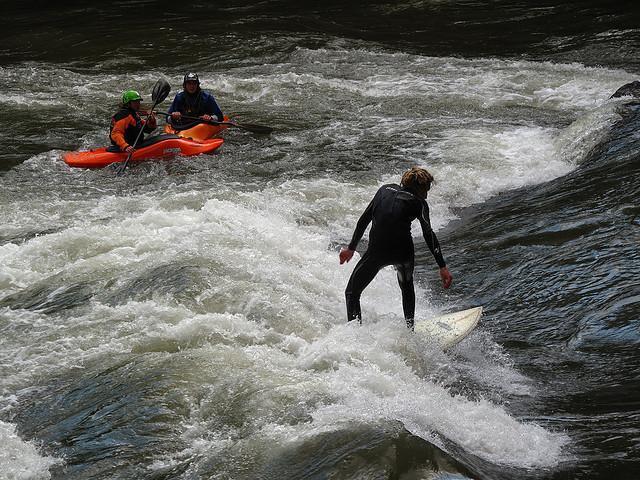How many people are in the water?
Give a very brief answer. 3. 